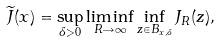<formula> <loc_0><loc_0><loc_500><loc_500>\widetilde { J } ( x ) = \sup _ { \delta > 0 } \liminf _ { R \rightarrow \infty } \inf _ { z \in B _ { x , \delta } } J _ { R } ( z ) ,</formula> 